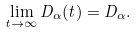<formula> <loc_0><loc_0><loc_500><loc_500>\lim _ { t \rightarrow \infty } D _ { \alpha } ( t ) = D _ { \alpha } .</formula> 